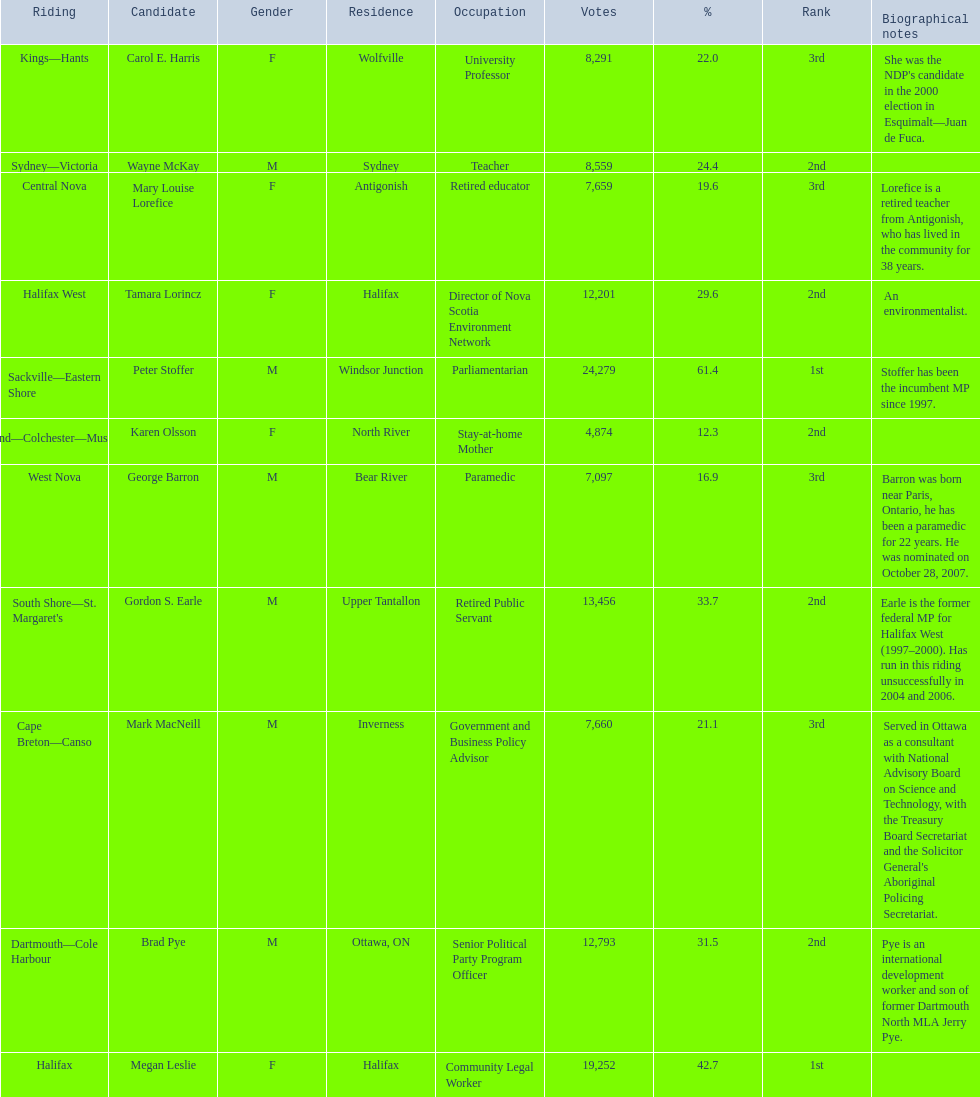Who are all the candidates? Mark MacNeill, Mary Louise Lorefice, Karen Olsson, Brad Pye, Megan Leslie, Tamara Lorincz, Carol E. Harris, Peter Stoffer, Gordon S. Earle, Wayne McKay, George Barron. How many votes did they receive? 7,660, 7,659, 4,874, 12,793, 19,252, 12,201, 8,291, 24,279, 13,456, 8,559, 7,097. And of those, how many were for megan leslie? 19,252. 